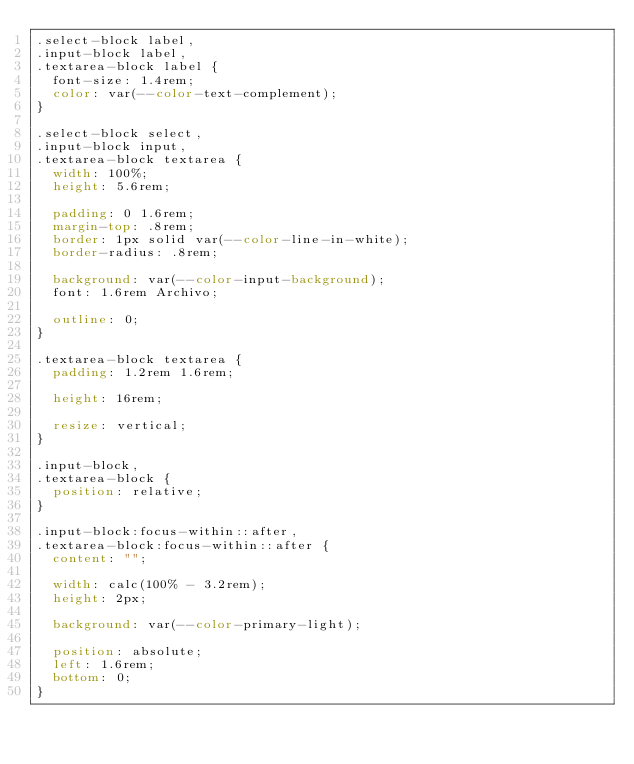Convert code to text. <code><loc_0><loc_0><loc_500><loc_500><_CSS_>.select-block label,
.input-block label,
.textarea-block label {
  font-size: 1.4rem;
  color: var(--color-text-complement);
}

.select-block select,
.input-block input,
.textarea-block textarea {
  width: 100%;
  height: 5.6rem;
  
  padding: 0 1.6rem;
  margin-top: .8rem;
  border: 1px solid var(--color-line-in-white);
  border-radius: .8rem;
  
  background: var(--color-input-background);
  font: 1.6rem Archivo;
  
  outline: 0;
}

.textarea-block textarea {
  padding: 1.2rem 1.6rem;
  
  height: 16rem;
  
  resize: vertical;
}

.input-block,
.textarea-block {
  position: relative;
}

.input-block:focus-within::after,
.textarea-block:focus-within::after {
  content: "";
  
  width: calc(100% - 3.2rem);
  height: 2px;
  
  background: var(--color-primary-light);
  
  position: absolute;
  left: 1.6rem;
  bottom: 0;
}</code> 